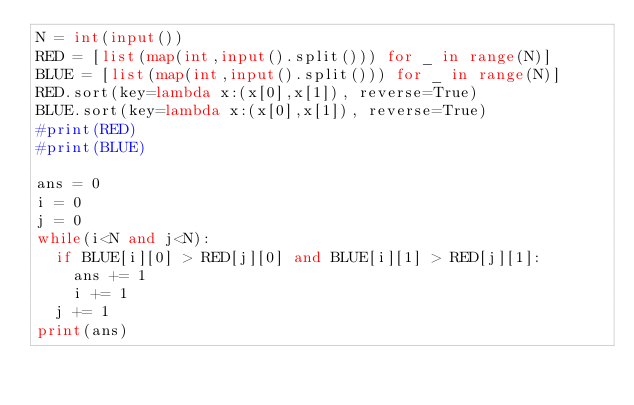<code> <loc_0><loc_0><loc_500><loc_500><_Python_>N = int(input())
RED = [list(map(int,input().split())) for _ in range(N)]
BLUE = [list(map(int,input().split())) for _ in range(N)]
RED.sort(key=lambda x:(x[0],x[1]), reverse=True)
BLUE.sort(key=lambda x:(x[0],x[1]), reverse=True)
#print(RED)
#print(BLUE)

ans = 0
i = 0
j = 0
while(i<N and j<N):
  if BLUE[i][0] > RED[j][0] and BLUE[i][1] > RED[j][1]:
    ans += 1
    i += 1
  j += 1
print(ans)</code> 